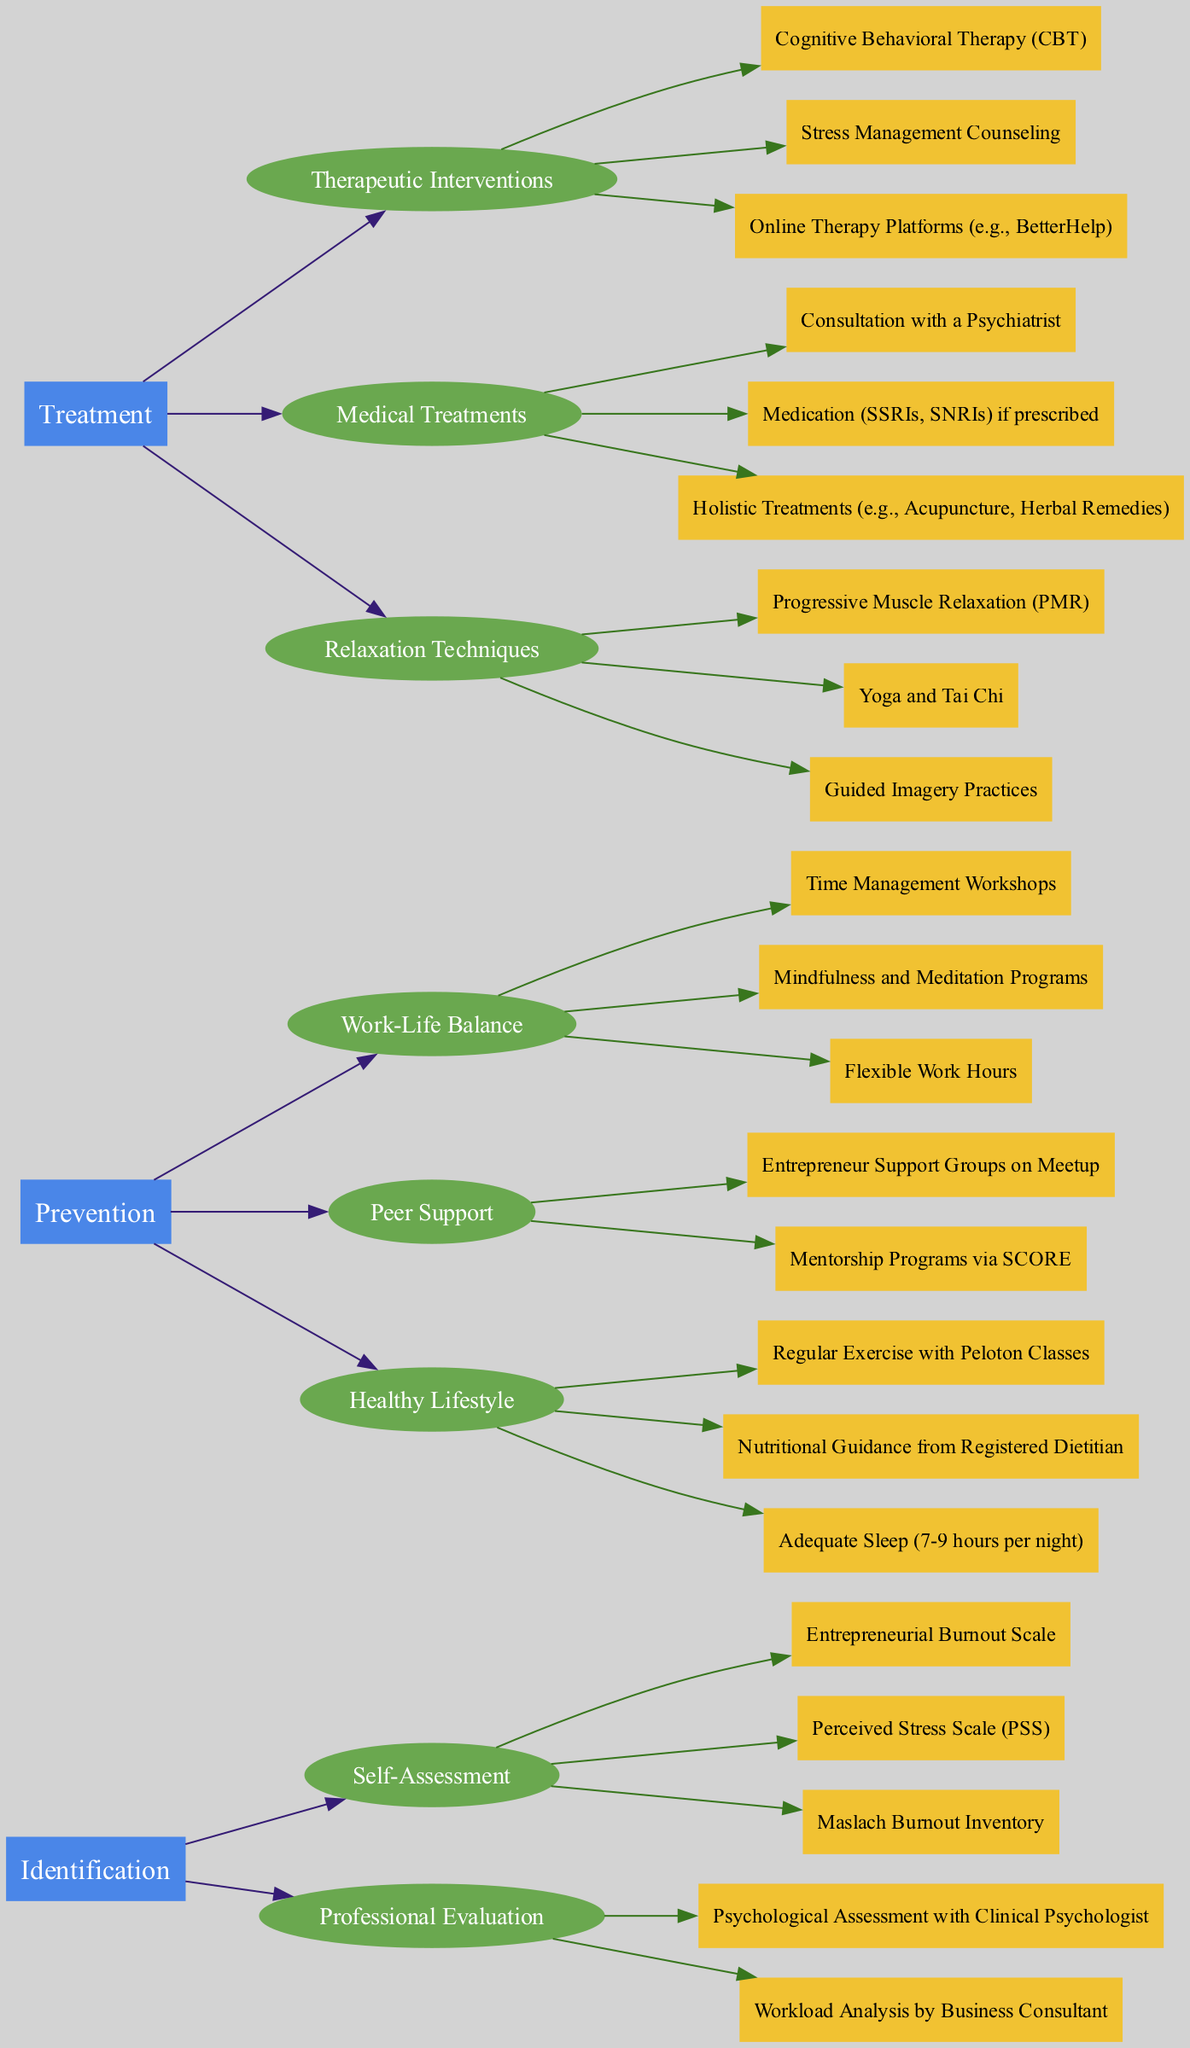What are the three main categories in the clinical pathway? The main categories in the clinical pathway are labeled as 'Identification', 'Prevention', and 'Treatment'. These are the primary nodes from which subcategories and strategies stem.
Answer: Identification, Prevention, Treatment How many strategies are listed under 'Prevention'? To determine the number of strategies under 'Prevention', count the strategies in the subcategories: 'Work-Life Balance', 'Peer Support', and 'Healthy Lifestyle'. Each of these has three strategies, totaling nine.
Answer: 9 Which strategy falls under 'Healthy Lifestyle'? Review the strategies listed under the subcategory 'Healthy Lifestyle'. The three strategies provided are 'Regular Exercise with Peloton Classes', 'Nutritional Guidance from Registered Dietitian', and 'Adequate Sleep (7-9 hours per night)'. Any one of these would be an acceptable answer.
Answer: Regular Exercise with Peloton Classes What are the two types of medical treatments listed? Looking under the 'Medical Treatments' section, two types explicitly mentioned are 'Consultation with a Psychiatrist' and 'Medication (SSRIs, SNRIs) if prescribed'. These are distinct types that address treatment.
Answer: Consultation with a Psychiatrist, Medication (SSRIs, SNRIs) Which subcategory contains 'Cognitive Behavioral Therapy (CBT)'? Identify the category and subcategory where 'Cognitive Behavioral Therapy (CBT)' is mentioned. It is listed under the 'Therapeutic Interventions' subcategory in the 'Treatment' category, indicating its classification as a therapeutic strategy.
Answer: Therapeutic Interventions How many professional evaluations are there? To find the number of professional evaluations, look at the 'Professional Evaluation' subcategory under 'Identification'. There are two evaluations mentioned: 'Psychological Assessment with Clinical Psychologist' and 'Workload Analysis by Business Consultant'. Thus, the count is two.
Answer: 2 Which two nodes initiate the 'Prevention' category? In the 'Prevention' category, the two initiating nodes are 'Work-Life Balance' and 'Peer Support'. These define the two main strategies for prevention before delving into specific techniques.
Answer: Work-Life Balance, Peer Support How many strategies are there in total under the 'Identification' category? Count the individual strategies listed in the 'Self-Assessment' and 'Professional Evaluation' subcategories. The self-assessment has three strategies, and the professional evaluation has two, giving a total of five strategies.
Answer: 5 